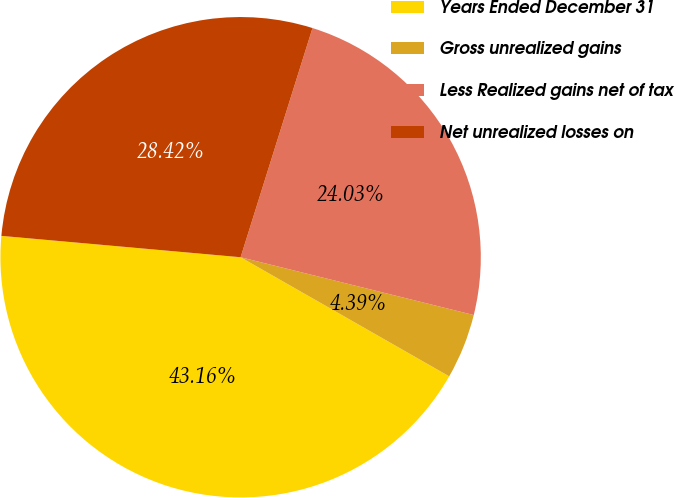<chart> <loc_0><loc_0><loc_500><loc_500><pie_chart><fcel>Years Ended December 31<fcel>Gross unrealized gains<fcel>Less Realized gains net of tax<fcel>Net unrealized losses on<nl><fcel>43.16%<fcel>4.39%<fcel>24.03%<fcel>28.42%<nl></chart> 